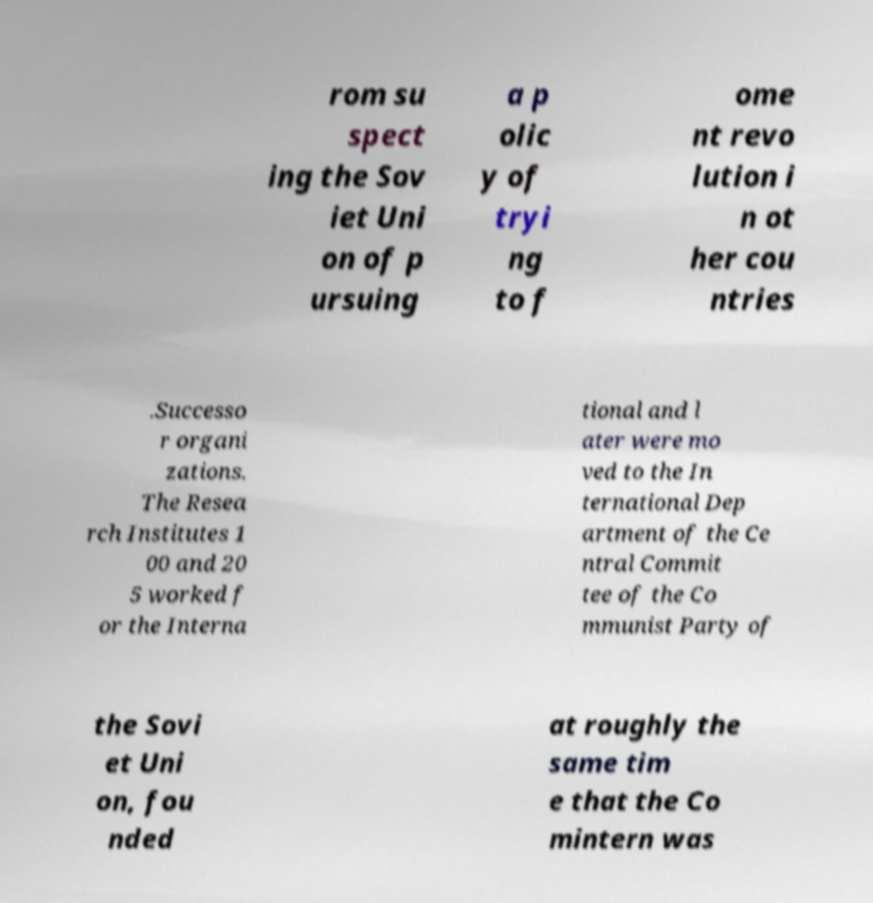What messages or text are displayed in this image? I need them in a readable, typed format. rom su spect ing the Sov iet Uni on of p ursuing a p olic y of tryi ng to f ome nt revo lution i n ot her cou ntries .Successo r organi zations. The Resea rch Institutes 1 00 and 20 5 worked f or the Interna tional and l ater were mo ved to the In ternational Dep artment of the Ce ntral Commit tee of the Co mmunist Party of the Sovi et Uni on, fou nded at roughly the same tim e that the Co mintern was 